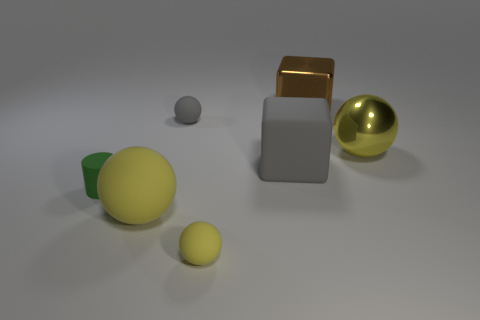Does the large shiny ball have the same color as the big thing that is left of the tiny yellow thing?
Keep it short and to the point. Yes. Are there fewer small blue cubes than objects?
Your answer should be compact. Yes. There is a large metal thing to the right of the brown cube; what is its color?
Make the answer very short. Yellow. There is a yellow matte object that is to the right of the yellow rubber ball that is behind the small yellow matte sphere; what shape is it?
Make the answer very short. Sphere. Are the brown cube and the large yellow sphere that is to the right of the large matte ball made of the same material?
Your response must be concise. Yes. There is a big metallic object that is the same color as the large rubber sphere; what is its shape?
Offer a very short reply. Sphere. How many gray rubber cubes have the same size as the gray matte ball?
Give a very brief answer. 0. Is the number of small yellow matte objects right of the green rubber cylinder less than the number of large rubber objects?
Make the answer very short. Yes. What number of yellow objects are right of the brown metal object?
Your response must be concise. 1. There is a matte ball to the right of the tiny sphere behind the large shiny object in front of the brown metallic thing; what is its size?
Provide a succinct answer. Small. 